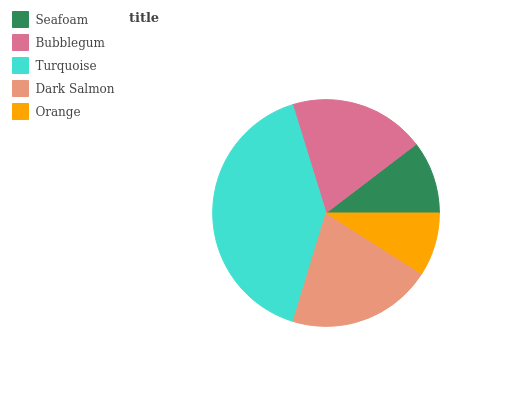Is Orange the minimum?
Answer yes or no. Yes. Is Turquoise the maximum?
Answer yes or no. Yes. Is Bubblegum the minimum?
Answer yes or no. No. Is Bubblegum the maximum?
Answer yes or no. No. Is Bubblegum greater than Seafoam?
Answer yes or no. Yes. Is Seafoam less than Bubblegum?
Answer yes or no. Yes. Is Seafoam greater than Bubblegum?
Answer yes or no. No. Is Bubblegum less than Seafoam?
Answer yes or no. No. Is Bubblegum the high median?
Answer yes or no. Yes. Is Bubblegum the low median?
Answer yes or no. Yes. Is Orange the high median?
Answer yes or no. No. Is Dark Salmon the low median?
Answer yes or no. No. 